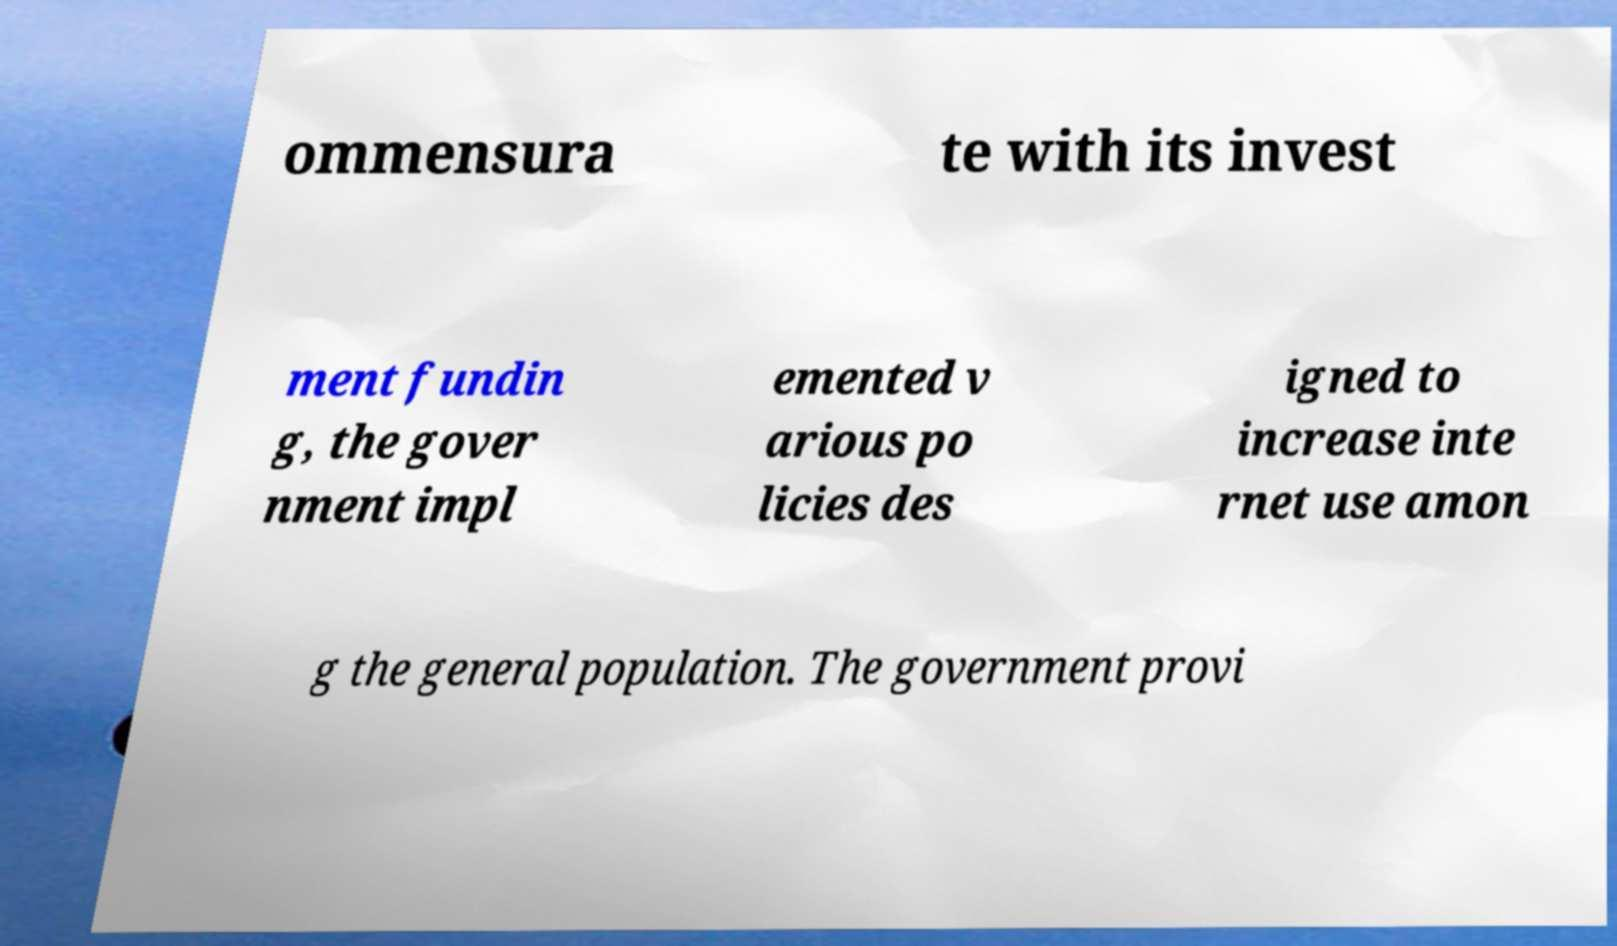What messages or text are displayed in this image? I need them in a readable, typed format. ommensura te with its invest ment fundin g, the gover nment impl emented v arious po licies des igned to increase inte rnet use amon g the general population. The government provi 